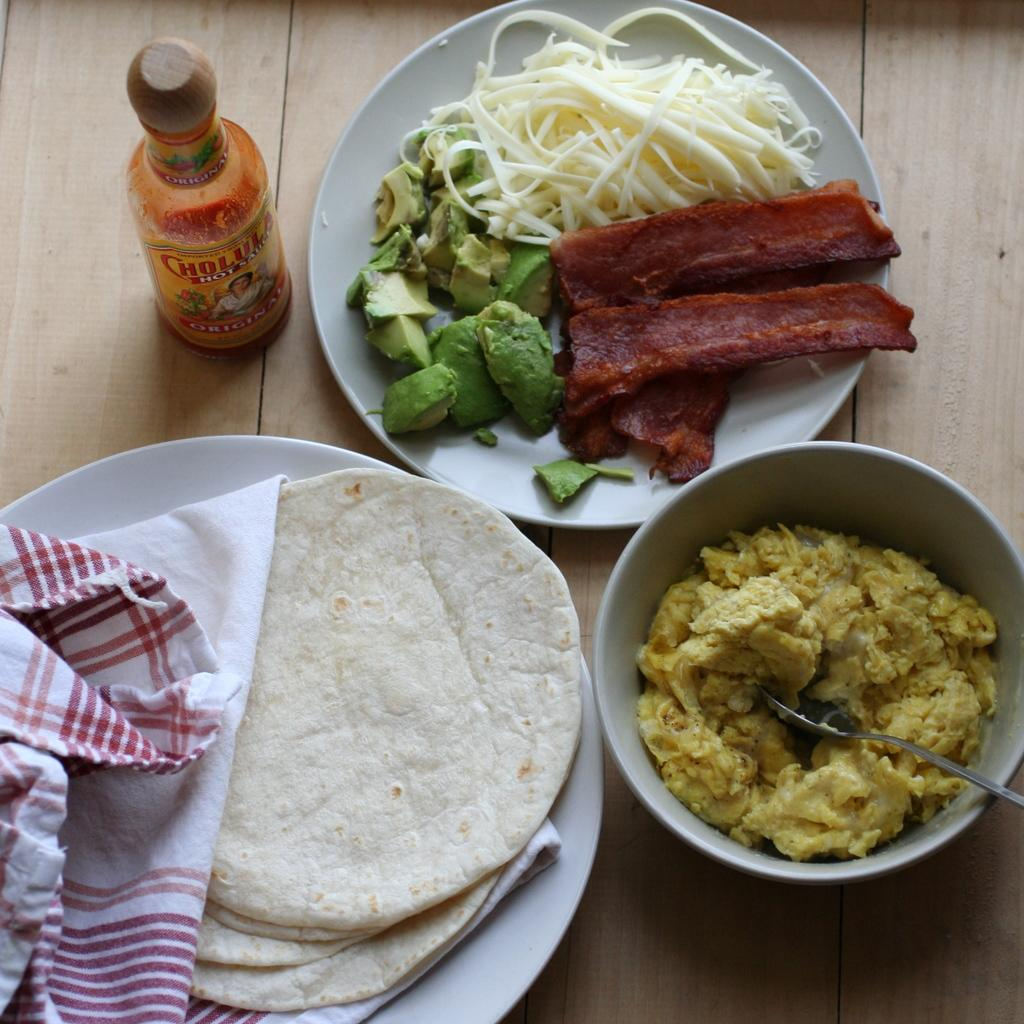What types of food items can be seen in the image? There are various food items in the image. What is used to serve the food in the image? There are plates in the image. What is the container for a liquid in the image? There is a bottle in the image. What utensils are present in the image? There are spoons in the image. What material is used for covering or decoration in the image? There is cloth in the image. What type of furniture is present in the image? There is a wooden table in the image. What type of scissors are used by the committee in the image? There is no committee or scissors present in the image. What room is the image taken in? The image does not provide information about the room or location where it was taken. 